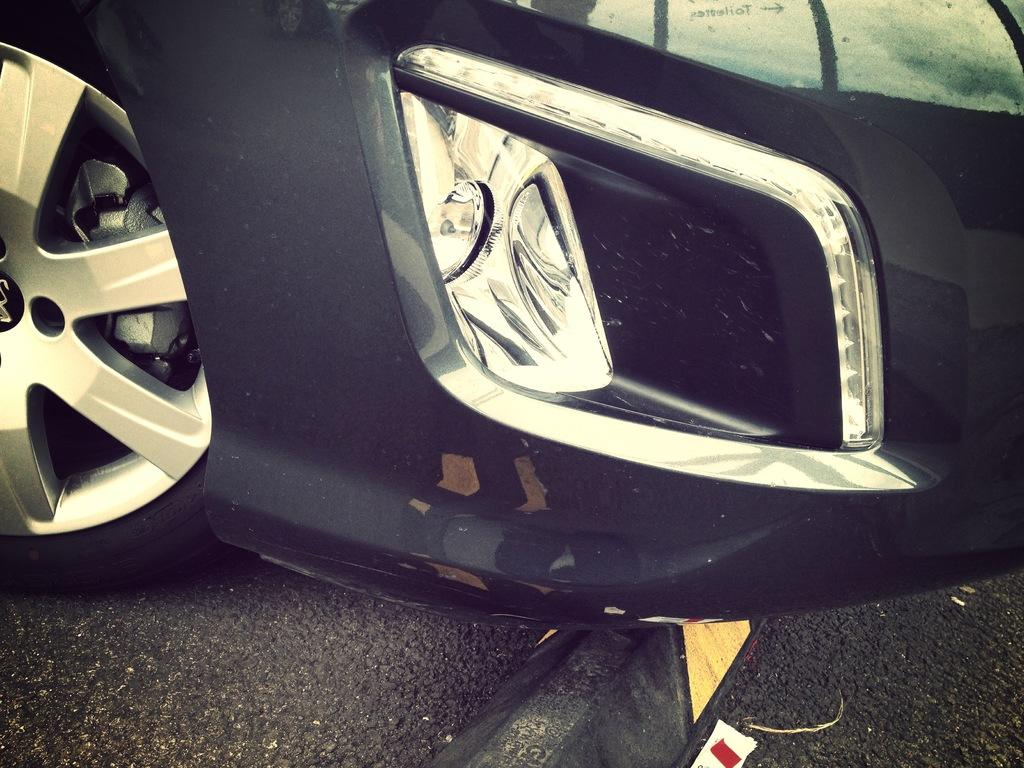What is the main object in the center of the image? There is a car tyre and a fog light in the center of the image. What is the purpose of the fog light? The fog light is used to improve visibility in foggy or low-light conditions. What is located at the bottom of the image? There is a road at the bottom of the image. How many grapes are hanging from the car tyre in the image? There are no grapes present in the image; it features a car tyre and a fog light. What is the mindset of the car tyre in the image? The car tyre does not have a mindset, as it is an inanimate object. 